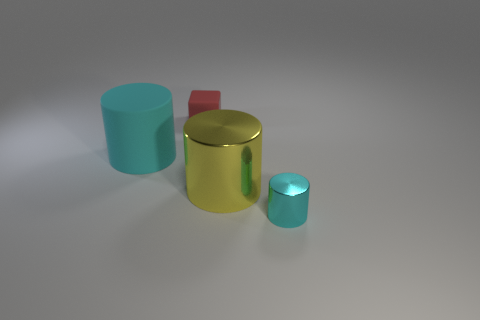Add 1 cyan matte cylinders. How many objects exist? 5 Add 1 big rubber cylinders. How many big rubber cylinders are left? 2 Add 4 blue metallic spheres. How many blue metallic spheres exist? 4 Subtract all cyan cylinders. How many cylinders are left? 1 Subtract all yellow cylinders. How many cylinders are left? 2 Subtract 0 purple spheres. How many objects are left? 4 Subtract all blocks. How many objects are left? 3 Subtract 1 cylinders. How many cylinders are left? 2 Subtract all cyan cylinders. Subtract all yellow balls. How many cylinders are left? 1 Subtract all purple cylinders. How many yellow blocks are left? 0 